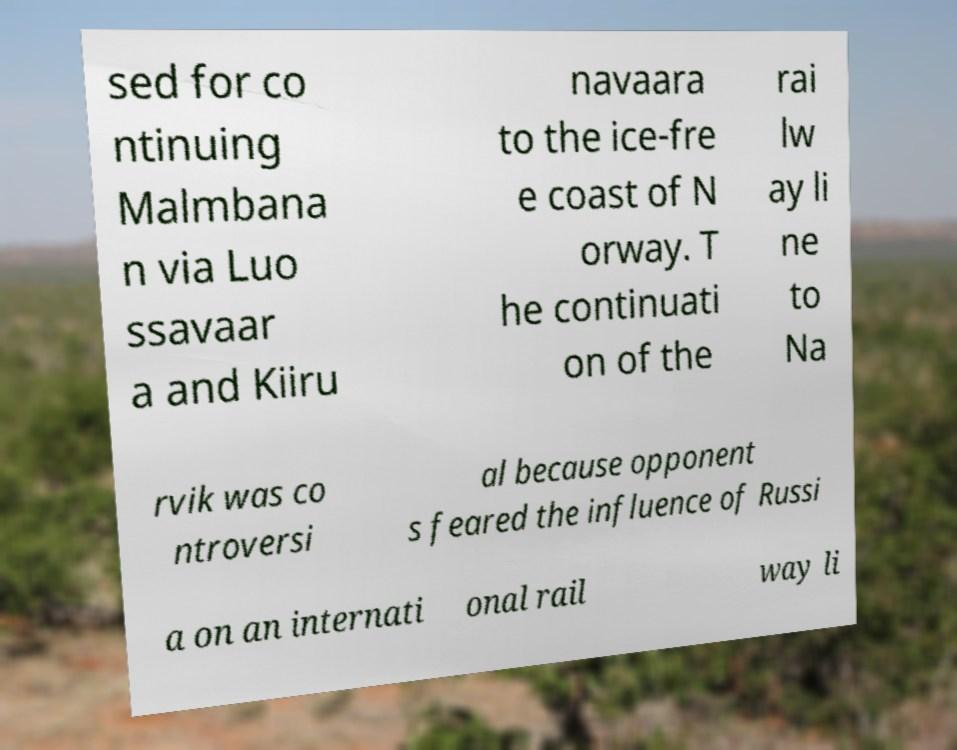Can you read and provide the text displayed in the image?This photo seems to have some interesting text. Can you extract and type it out for me? sed for co ntinuing Malmbana n via Luo ssavaar a and Kiiru navaara to the ice-fre e coast of N orway. T he continuati on of the rai lw ay li ne to Na rvik was co ntroversi al because opponent s feared the influence of Russi a on an internati onal rail way li 